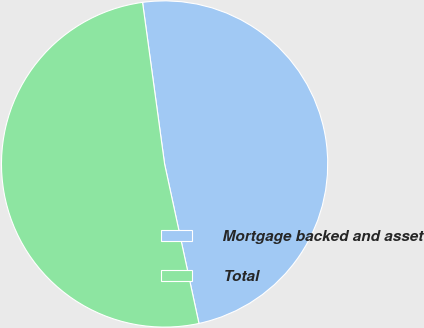Convert chart. <chart><loc_0><loc_0><loc_500><loc_500><pie_chart><fcel>Mortgage backed and asset<fcel>Total<nl><fcel>48.78%<fcel>51.22%<nl></chart> 